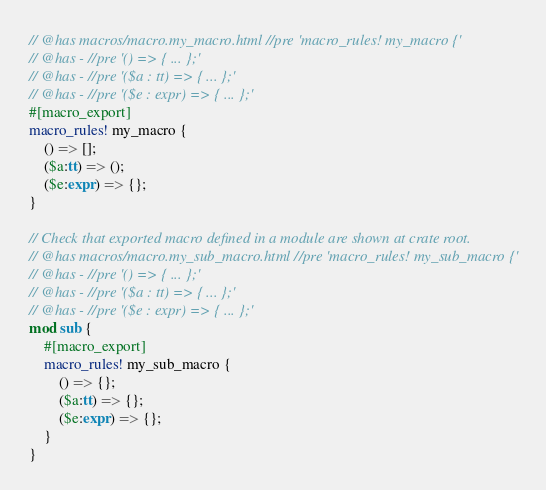Convert code to text. <code><loc_0><loc_0><loc_500><loc_500><_Rust_>// @has macros/macro.my_macro.html //pre 'macro_rules! my_macro {'
// @has - //pre '() => { ... };'
// @has - //pre '($a : tt) => { ... };'
// @has - //pre '($e : expr) => { ... };'
#[macro_export]
macro_rules! my_macro {
    () => [];
    ($a:tt) => ();
    ($e:expr) => {};
}

// Check that exported macro defined in a module are shown at crate root.
// @has macros/macro.my_sub_macro.html //pre 'macro_rules! my_sub_macro {'
// @has - //pre '() => { ... };'
// @has - //pre '($a : tt) => { ... };'
// @has - //pre '($e : expr) => { ... };'
mod sub {
    #[macro_export]
    macro_rules! my_sub_macro {
        () => {};
        ($a:tt) => {};
        ($e:expr) => {};
    }
}
</code> 